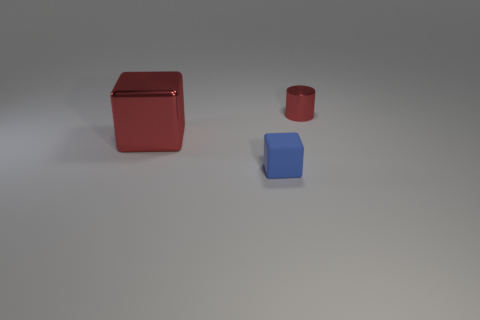Does the metallic cube have the same color as the small cylinder?
Offer a terse response. Yes. What size is the cube that is the same color as the small metal cylinder?
Keep it short and to the point. Large. What number of objects are either tiny things that are behind the large thing or small things that are behind the small blue rubber thing?
Offer a very short reply. 1. Are there fewer tiny blue rubber balls than cylinders?
Your response must be concise. Yes. There is a cylinder that is the same size as the matte block; what is it made of?
Your answer should be very brief. Metal. There is a object that is behind the big red thing; is its size the same as the block that is behind the blue rubber object?
Your answer should be compact. No. Is there a small cylinder that has the same material as the big red block?
Your answer should be compact. Yes. What number of objects are either metallic things that are on the right side of the blue cube or yellow metal objects?
Offer a terse response. 1. Is the material of the thing right of the tiny cube the same as the big red block?
Make the answer very short. Yes. Do the tiny metal object and the matte object have the same shape?
Provide a short and direct response. No. 